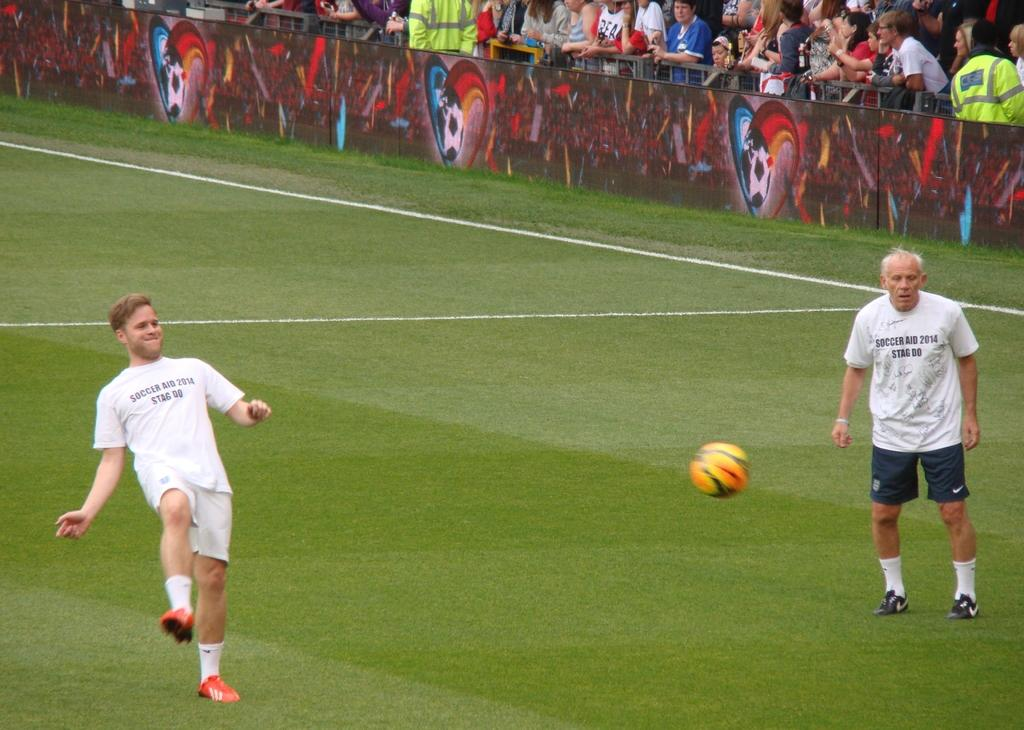Provide a one-sentence caption for the provided image. Soccer player on the field wearing a white shirt that says Soccer Aid 2014. 